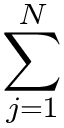Convert formula to latex. <formula><loc_0><loc_0><loc_500><loc_500>\sum _ { j = 1 } ^ { N }</formula> 